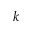<formula> <loc_0><loc_0><loc_500><loc_500>k</formula> 